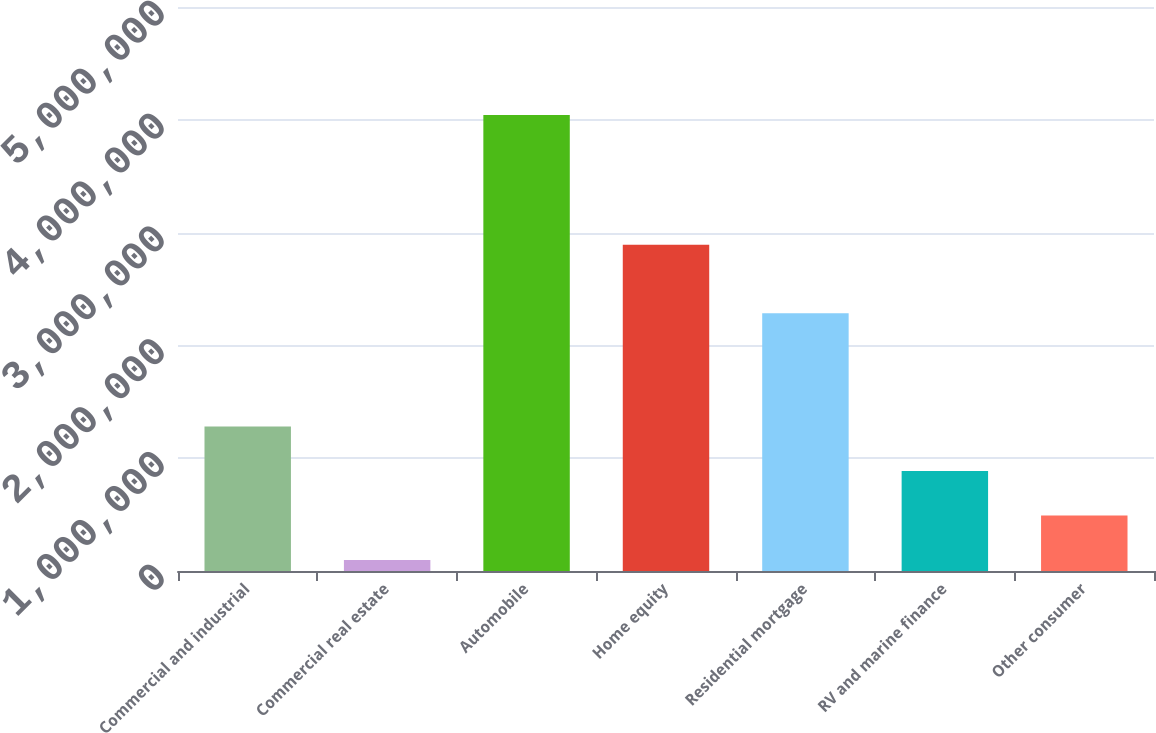<chart> <loc_0><loc_0><loc_500><loc_500><bar_chart><fcel>Commercial and industrial<fcel>Commercial real estate<fcel>Automobile<fcel>Home equity<fcel>Residential mortgage<fcel>RV and marine finance<fcel>Other consumer<nl><fcel>1.28097e+06<fcel>96975<fcel>4.04361e+06<fcel>2.89133e+06<fcel>2.28512e+06<fcel>886302<fcel>491639<nl></chart> 